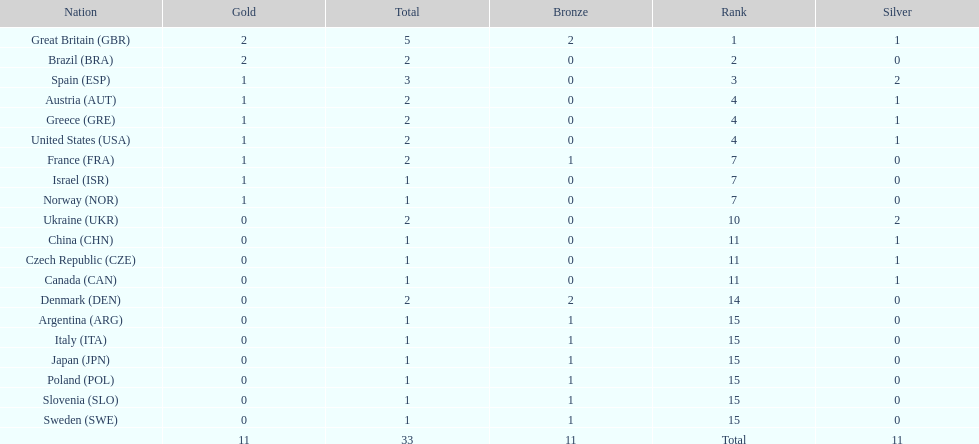How many countries won at least 2 medals in sailing? 9. 